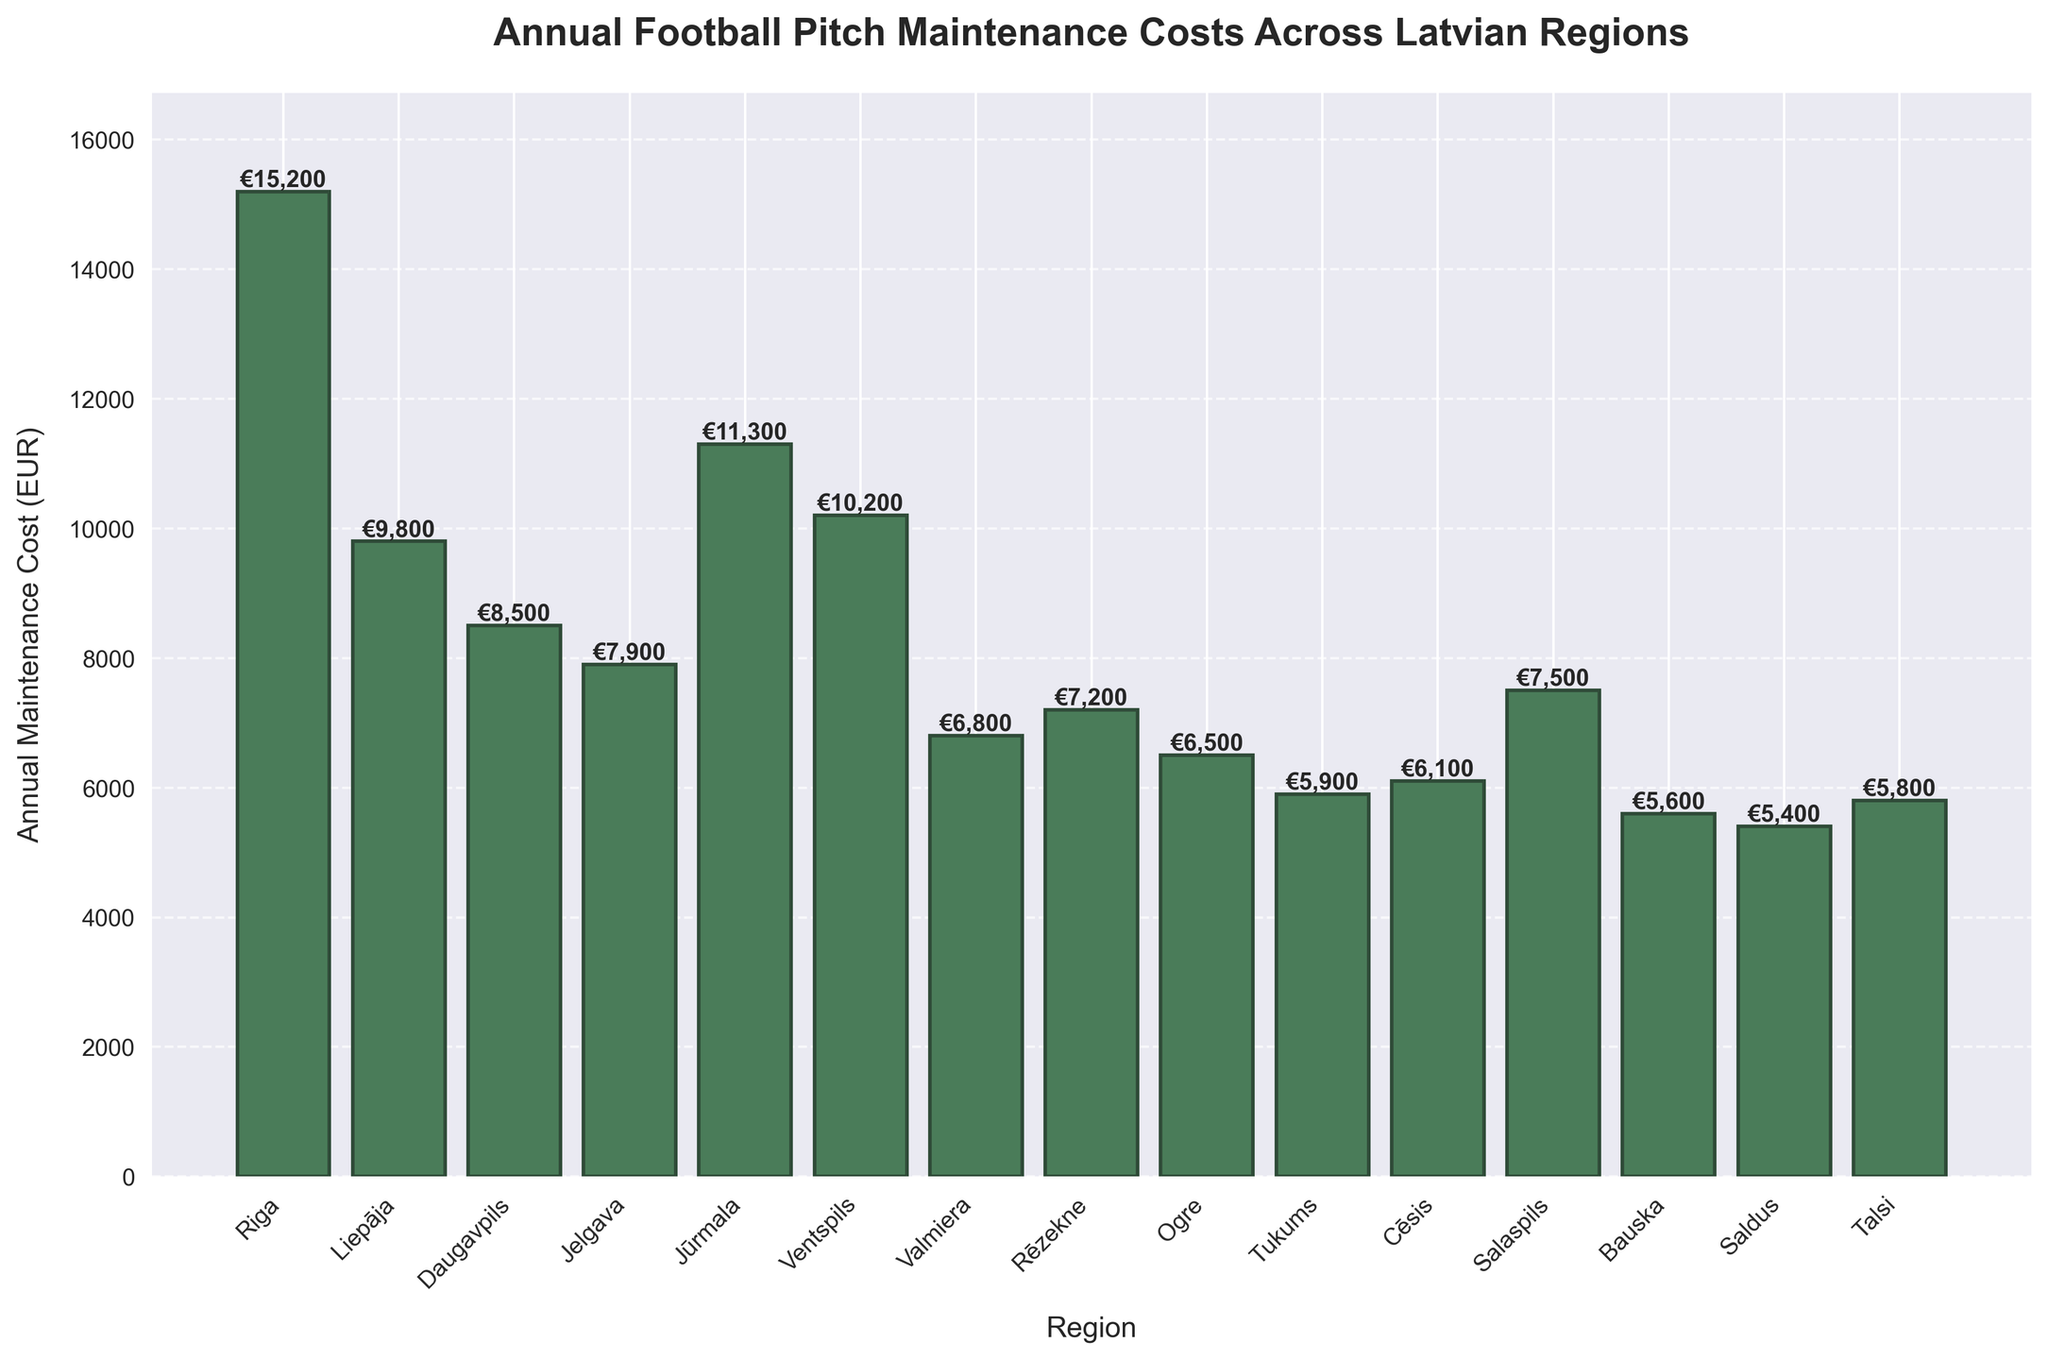Which region has the highest annual football pitch maintenance cost? The region with the highest bar on the chart represents the highest annual maintenance cost. Riga has the highest bar at €15,200.
Answer: Riga Which region has the lowest annual football pitch maintenance cost? The region with the shortest bar on the chart represents the lowest annual maintenance cost. Bauska has the shortest bar at €5,600.
Answer: Bauska What is the total annual maintenance cost for Ventspils and Liepāja combined? Find the height of the bars for Ventspils (€10,200) and Liepāja (€9,800) and add them together. The total is €10,200 + €9,800 = €20,000.
Answer: €20,000 How much higher is Riga's maintenance cost compared to Daugavpils? Subtract Daugavpils' maintenance cost (€8,500) from Riga's maintenance cost (€15,200). The difference is €15,200 - €8,500 = €6,700.
Answer: €6,700 Which region has a higher maintenance cost, Jūrmala or Jelgava, and by how much? Compare the heights of the bars for Jūrmala (€11,300) and Jelgava (€7,900). Subtract Jelgava's cost from Jūrmala's. The difference is €11,300 - €7,900 = €3,400.
Answer: Jūrmala, €3,400 What is the average annual maintenance cost across all regions? Sum all the annual maintenance costs provided and divide by the number of regions: (€15,200 + €9,800 + €8,500 + €7,900 + €11,300 + €10,200 + €6,800 + €7,200 + €6,500 + €5,900 + €6,100 + €7,500 + €5,600 + €5,400 + €5,800) / 15. The total sum is €109,700. So the average is €109,700 / 15 = €7,313.33.
Answer: €7,313.33 What is the difference in annual maintenance cost between the region with the highest cost and the average cost? Riga has the highest cost at €15,200. The average cost is €7,313.33. Subtract the average from Riga's cost: €15,200 - €7,313.33 = €7,886.67.
Answer: €7,886.67 How many regions have an annual maintenance cost higher than €10,000? Look at the bars that exceed the €10,000 mark. Riga (€15,200), Liepāja (€9,800), Jūrmala (€11,300), and Ventspils (€10,200). There are 3 regions (excluding Liepāja as it is below €10,000).
Answer: 3 